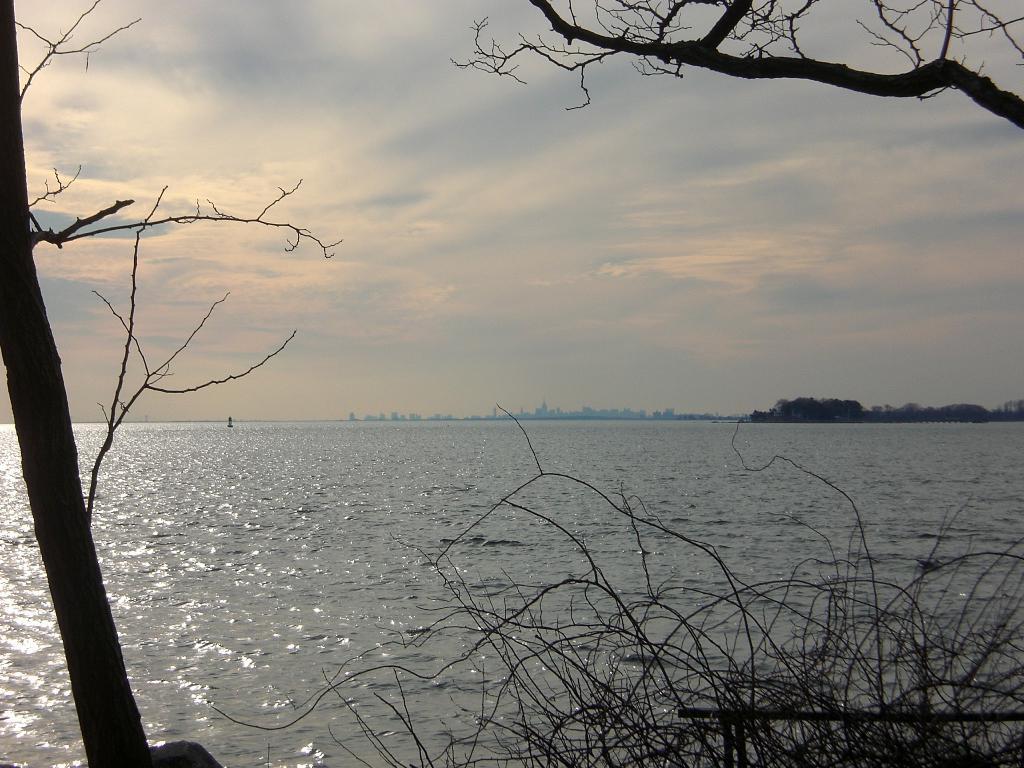Can you describe this image briefly? In this picture we can see few trees, water and clouds. 